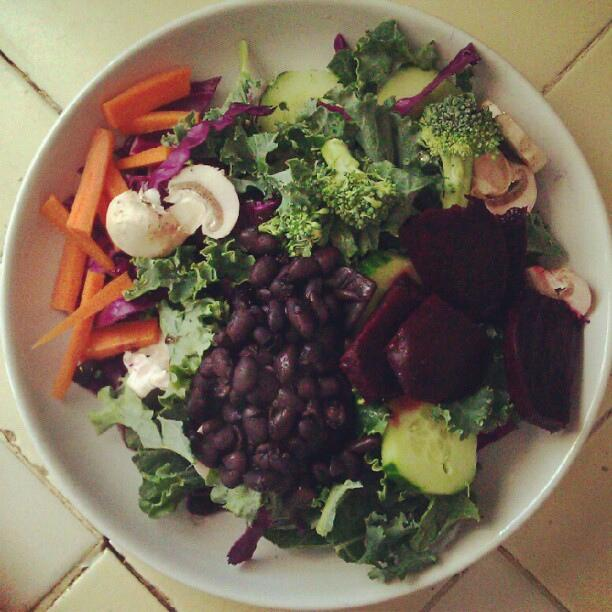What are the sliced red vegetables on the right side of dish called? beets 